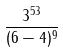Convert formula to latex. <formula><loc_0><loc_0><loc_500><loc_500>\frac { 3 ^ { 5 3 } } { ( 6 - 4 ) ^ { 9 } }</formula> 